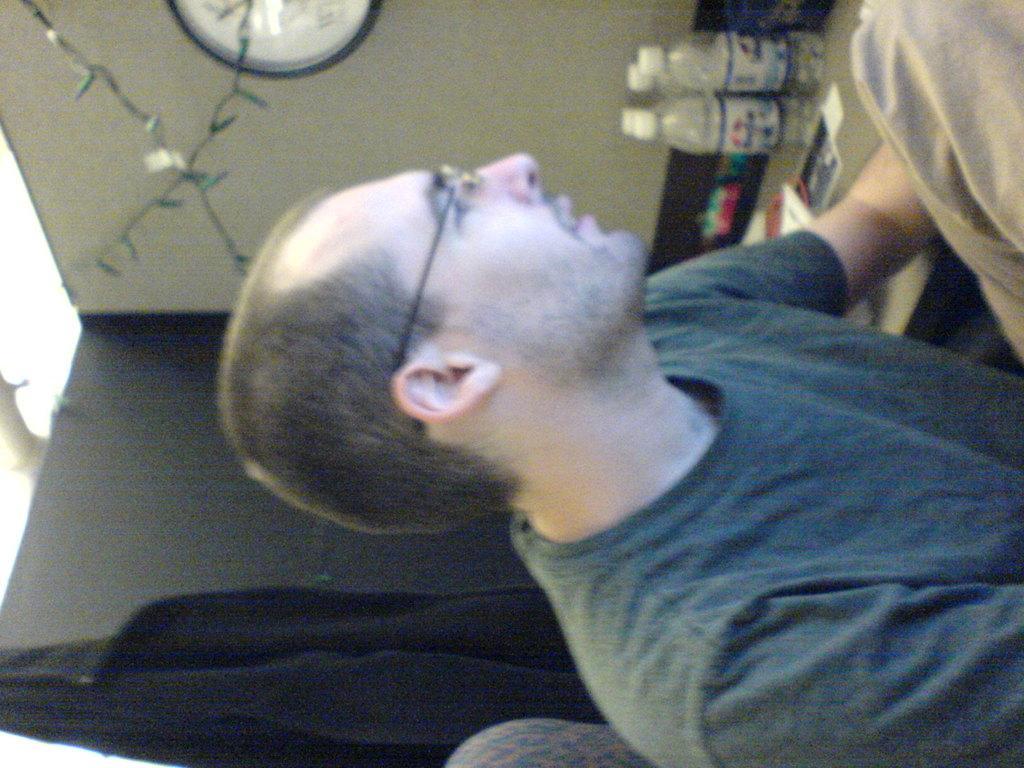Please provide a concise description of this image. In this image there is a person sitting, there are bottles on the surface, there are objects on the surface, there is a wall clock truncated, there is a cloth hanged on the object, there is a chair truncated. 